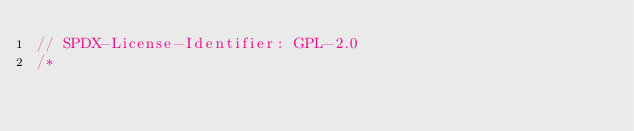Convert code to text. <code><loc_0><loc_0><loc_500><loc_500><_C_>// SPDX-License-Identifier: GPL-2.0
/*</code> 